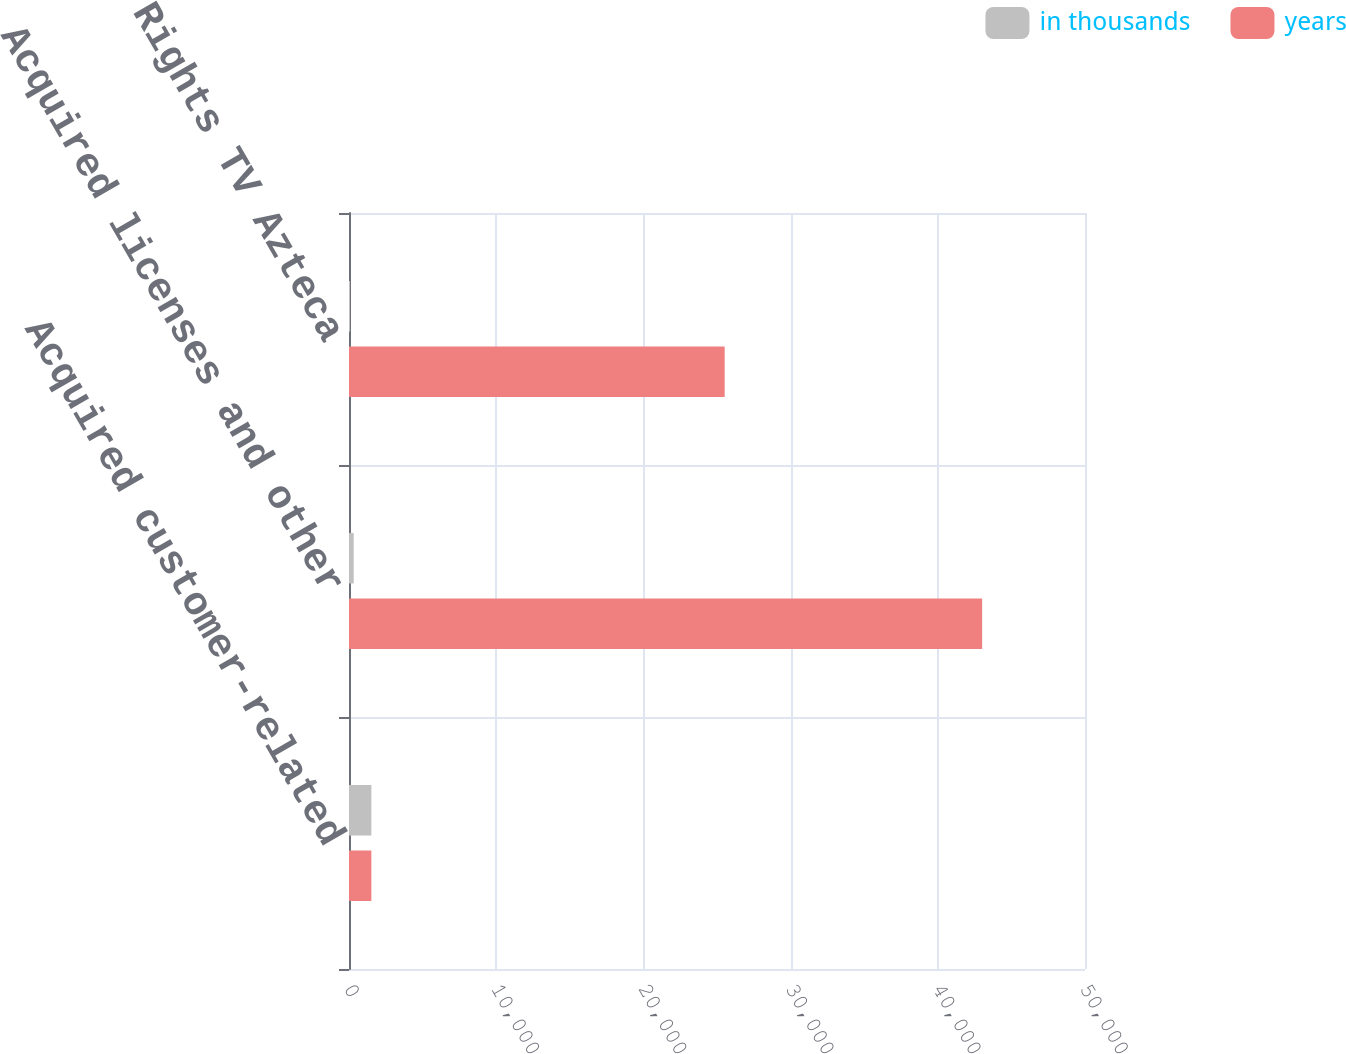<chart> <loc_0><loc_0><loc_500><loc_500><stacked_bar_chart><ecel><fcel>Acquired customer-related<fcel>Acquired licenses and other<fcel>Economic Rights TV Azteca<nl><fcel>in thousands<fcel>1520<fcel>320<fcel>70<nl><fcel>years<fcel>1520<fcel>43012<fcel>25522<nl></chart> 